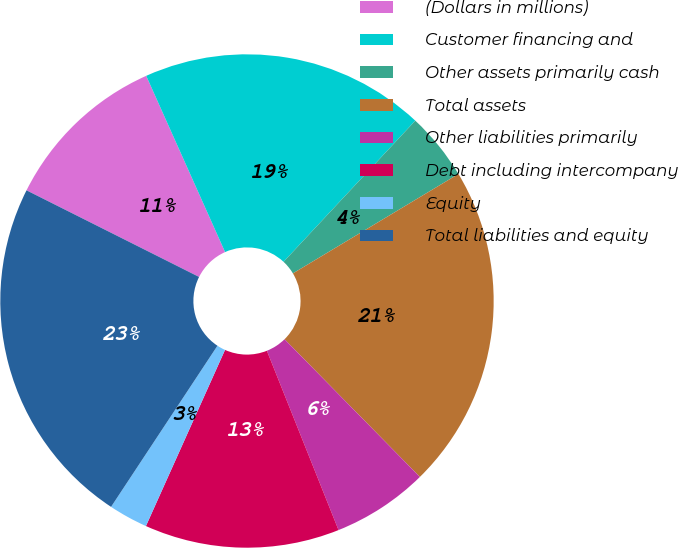Convert chart. <chart><loc_0><loc_0><loc_500><loc_500><pie_chart><fcel>(Dollars in millions)<fcel>Customer financing and<fcel>Other assets primarily cash<fcel>Total assets<fcel>Other liabilities primarily<fcel>Debt including intercompany<fcel>Equity<fcel>Total liabilities and equity<nl><fcel>10.9%<fcel>18.65%<fcel>4.44%<fcel>21.25%<fcel>6.31%<fcel>12.77%<fcel>2.57%<fcel>23.12%<nl></chart> 